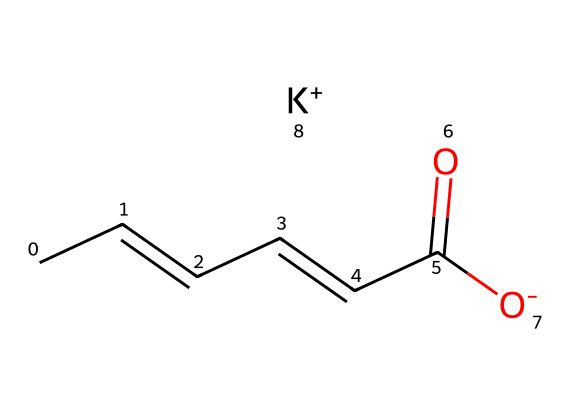What is the molecular formula of potassium sorbate? The molecular formula can be derived from the SMILES representation by identifying and counting the elements. From the SMILES, it consists of 6 Carbon (C), 8 Hydrogen (H), 1 Oxygen (O), and 1 Potassium (K).
Answer: C6H7O2K How many double bonds are present in potassium sorbate? Inspecting the chemical structure from the SMILES shows there are two double bonds between carbon atoms and a double bond with oxygen. Hence, there are a total of two double bonds.
Answer: 2 What functional group is present in potassium sorbate? The compound has a carboxylate group (derived from the carboxylic acid) as indicated by the "-O-" and is connected to the potassium ion. This functional group is responsible for its preservative properties.
Answer: carboxylate What is the charge on the potassium ion in potassium sorbate? In the SMILES representation, the potassium (K) is denoted with a "+" sign, indicating that it carries a single positive charge.
Answer: +1 How many total atoms are present in potassium sorbate? From the molecular formula derived earlier (C6H7O2K), we sum the individual atoms: 6 Carbons + 7 Hydrogens + 2 Oxygens + 1 Potassium, which equals 16 total atoms.
Answer: 16 What role does potassium play in the structure of potassium sorbate? Potassium serves as a counterion to stabilize the negative charge of the carboxylate group. This ionic interaction is crucial for the preservative's solubility and reactivity.
Answer: counterion 